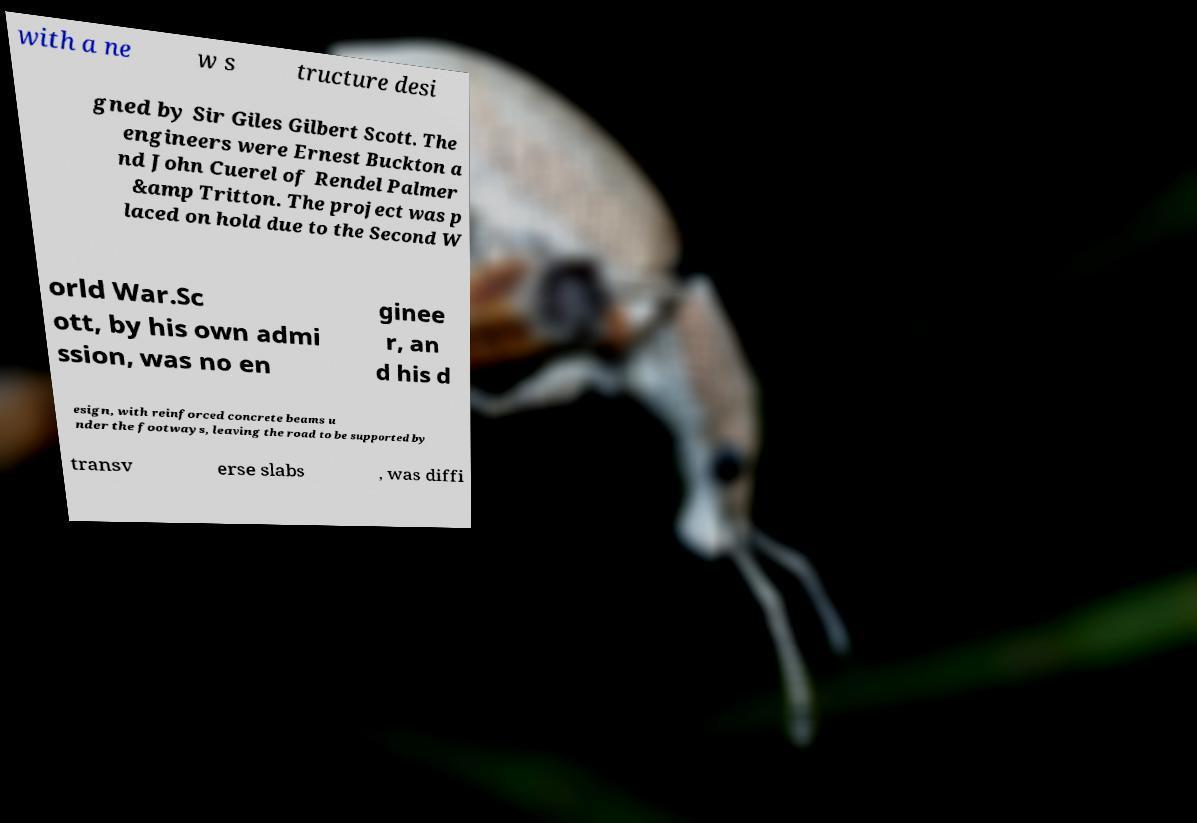Please identify and transcribe the text found in this image. with a ne w s tructure desi gned by Sir Giles Gilbert Scott. The engineers were Ernest Buckton a nd John Cuerel of Rendel Palmer &amp Tritton. The project was p laced on hold due to the Second W orld War.Sc ott, by his own admi ssion, was no en ginee r, an d his d esign, with reinforced concrete beams u nder the footways, leaving the road to be supported by transv erse slabs , was diffi 